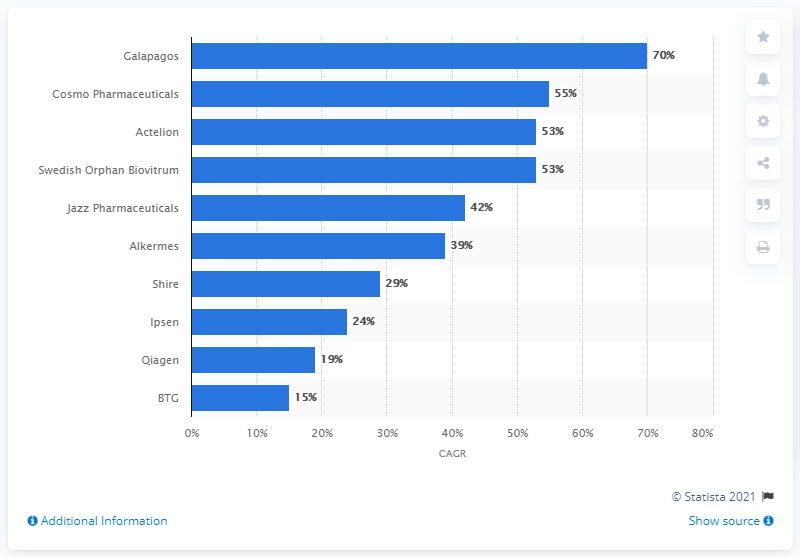Outline some significant characteristics in this image. Jazz Pharmaceuticals, an Irish company, had a Compound Annual Growth Rate (CAGR) of 42 percent between 2012 and 2016. 